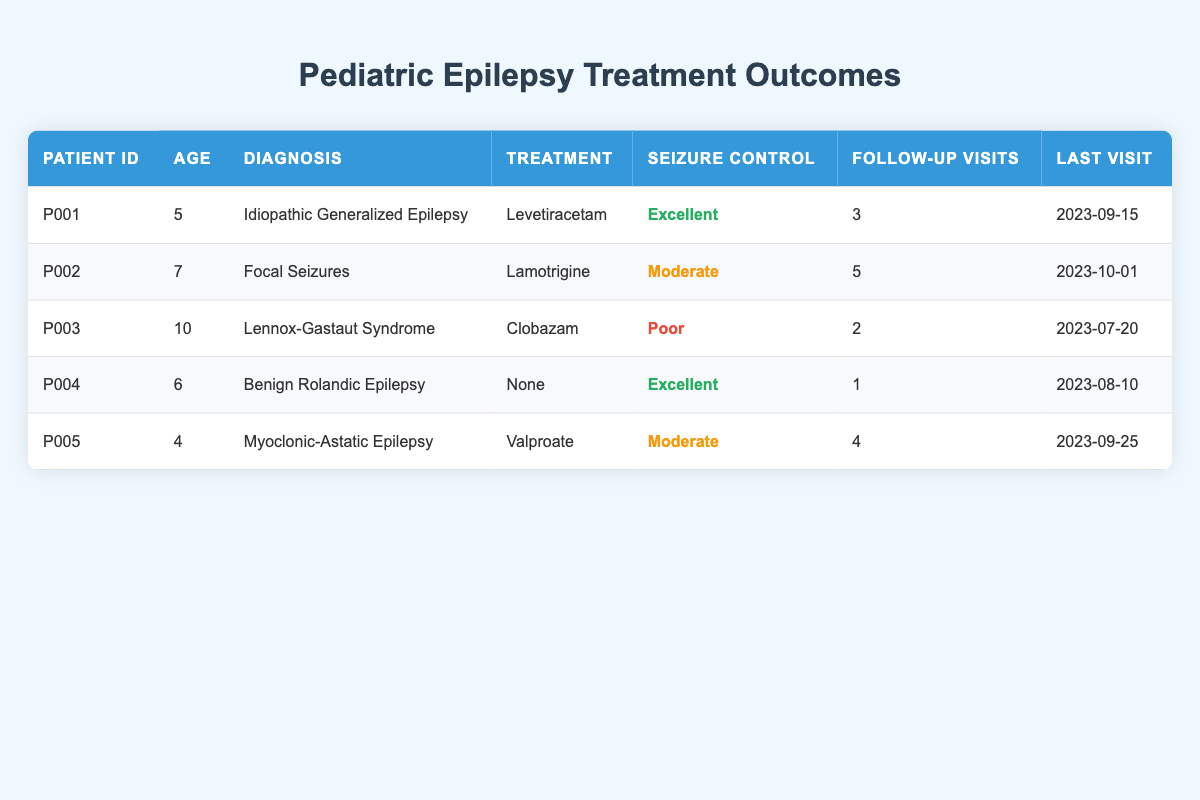What treatment was given to patient P003? Patient P003 is diagnosed with Lennox-Gastaut Syndrome, and according to the table, the treatment provided was Clobazam.
Answer: Clobazam How many follow-up visits did patient P002 have? Referring to the table, patient P002 has been recorded as having 5 follow-up visits.
Answer: 5 Is seizure control for patient P004 considered poor? Checking the table, patient P004 has seizure control categorized as Excellent, therefore it is false to say it is poor.
Answer: No What is the average age of the patients listed? The ages of the patients are 5, 7, 10, 6, and 4. Adding these gives 5 + 7 + 10 + 6 + 4 = 32. There are 5 patients, so the average age is 32 / 5 = 6.4.
Answer: 6.4 Which patient had the last visit on 2023-10-01? By looking at the data, the patient with ID P002 had the last visit on 2023-10-01.
Answer: P002 What percentage of patients have excellent seizure control? There are a total of 5 patients, out of which 2 patients (P001 and P004) have excellent seizure control. Therefore, the percentage is (2/5) * 100 = 40%.
Answer: 40% Compare the number of follow-up visits for patients with excellent seizure control to those with poor seizure control. Patients P001 and P004 had excellent seizure control with 3 and 1 follow-up visits respectively, totaling 4. Patient P003 had poor seizure control with 2 follow-up visits. Therefore, the comparison shows that those with excellent seizure control (4 visits) had more follow-up visits compared to the one with poor seizure control (2 visits).
Answer: 4 vs 2 Does patient P005 have the most follow-up visits among those listed? Evaluating the follow-up visits, P005 with 4 visits ranks below P002 who has 5 visits. Hence, patient P005 does not have the most follow-up visits.
Answer: No 